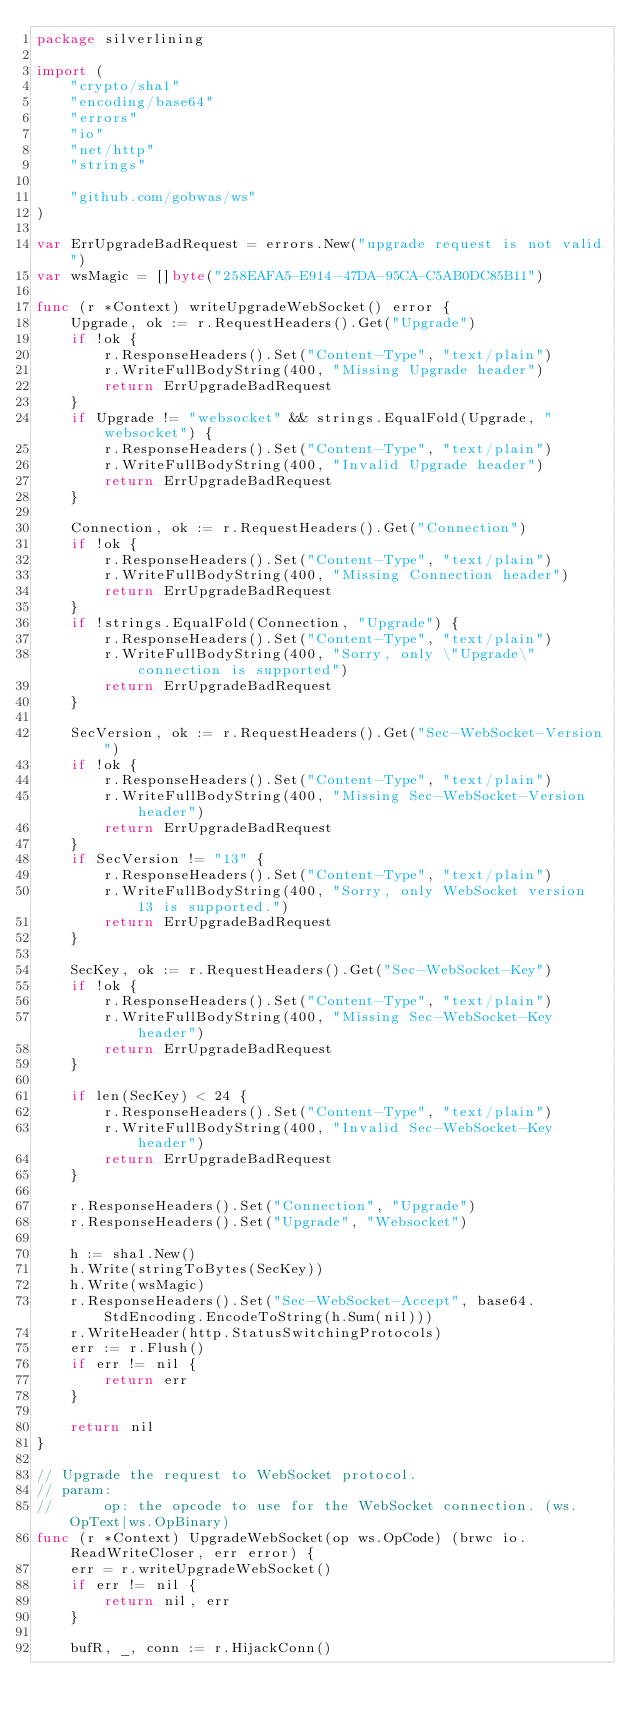Convert code to text. <code><loc_0><loc_0><loc_500><loc_500><_Go_>package silverlining

import (
	"crypto/sha1"
	"encoding/base64"
	"errors"
	"io"
	"net/http"
	"strings"

	"github.com/gobwas/ws"
)

var ErrUpgradeBadRequest = errors.New("upgrade request is not valid")
var wsMagic = []byte("258EAFA5-E914-47DA-95CA-C5AB0DC85B11")

func (r *Context) writeUpgradeWebSocket() error {
	Upgrade, ok := r.RequestHeaders().Get("Upgrade")
	if !ok {
		r.ResponseHeaders().Set("Content-Type", "text/plain")
		r.WriteFullBodyString(400, "Missing Upgrade header")
		return ErrUpgradeBadRequest
	}
	if Upgrade != "websocket" && strings.EqualFold(Upgrade, "websocket") {
		r.ResponseHeaders().Set("Content-Type", "text/plain")
		r.WriteFullBodyString(400, "Invalid Upgrade header")
		return ErrUpgradeBadRequest
	}

	Connection, ok := r.RequestHeaders().Get("Connection")
	if !ok {
		r.ResponseHeaders().Set("Content-Type", "text/plain")
		r.WriteFullBodyString(400, "Missing Connection header")
		return ErrUpgradeBadRequest
	}
	if !strings.EqualFold(Connection, "Upgrade") {
		r.ResponseHeaders().Set("Content-Type", "text/plain")
		r.WriteFullBodyString(400, "Sorry, only \"Upgrade\" connection is supported")
		return ErrUpgradeBadRequest
	}

	SecVersion, ok := r.RequestHeaders().Get("Sec-WebSocket-Version")
	if !ok {
		r.ResponseHeaders().Set("Content-Type", "text/plain")
		r.WriteFullBodyString(400, "Missing Sec-WebSocket-Version header")
		return ErrUpgradeBadRequest
	}
	if SecVersion != "13" {
		r.ResponseHeaders().Set("Content-Type", "text/plain")
		r.WriteFullBodyString(400, "Sorry, only WebSocket version 13 is supported.")
		return ErrUpgradeBadRequest
	}

	SecKey, ok := r.RequestHeaders().Get("Sec-WebSocket-Key")
	if !ok {
		r.ResponseHeaders().Set("Content-Type", "text/plain")
		r.WriteFullBodyString(400, "Missing Sec-WebSocket-Key header")
		return ErrUpgradeBadRequest
	}

	if len(SecKey) < 24 {
		r.ResponseHeaders().Set("Content-Type", "text/plain")
		r.WriteFullBodyString(400, "Invalid Sec-WebSocket-Key header")
		return ErrUpgradeBadRequest
	}

	r.ResponseHeaders().Set("Connection", "Upgrade")
	r.ResponseHeaders().Set("Upgrade", "Websocket")

	h := sha1.New()
	h.Write(stringToBytes(SecKey))
	h.Write(wsMagic)
	r.ResponseHeaders().Set("Sec-WebSocket-Accept", base64.StdEncoding.EncodeToString(h.Sum(nil)))
	r.WriteHeader(http.StatusSwitchingProtocols)
	err := r.Flush()
	if err != nil {
		return err
	}

	return nil
}

// Upgrade the request to WebSocket protocol.
// param:
// 		op: the opcode to use for the WebSocket connection. (ws.OpText|ws.OpBinary)
func (r *Context) UpgradeWebSocket(op ws.OpCode) (brwc io.ReadWriteCloser, err error) {
	err = r.writeUpgradeWebSocket()
	if err != nil {
		return nil, err
	}

	bufR, _, conn := r.HijackConn()
</code> 